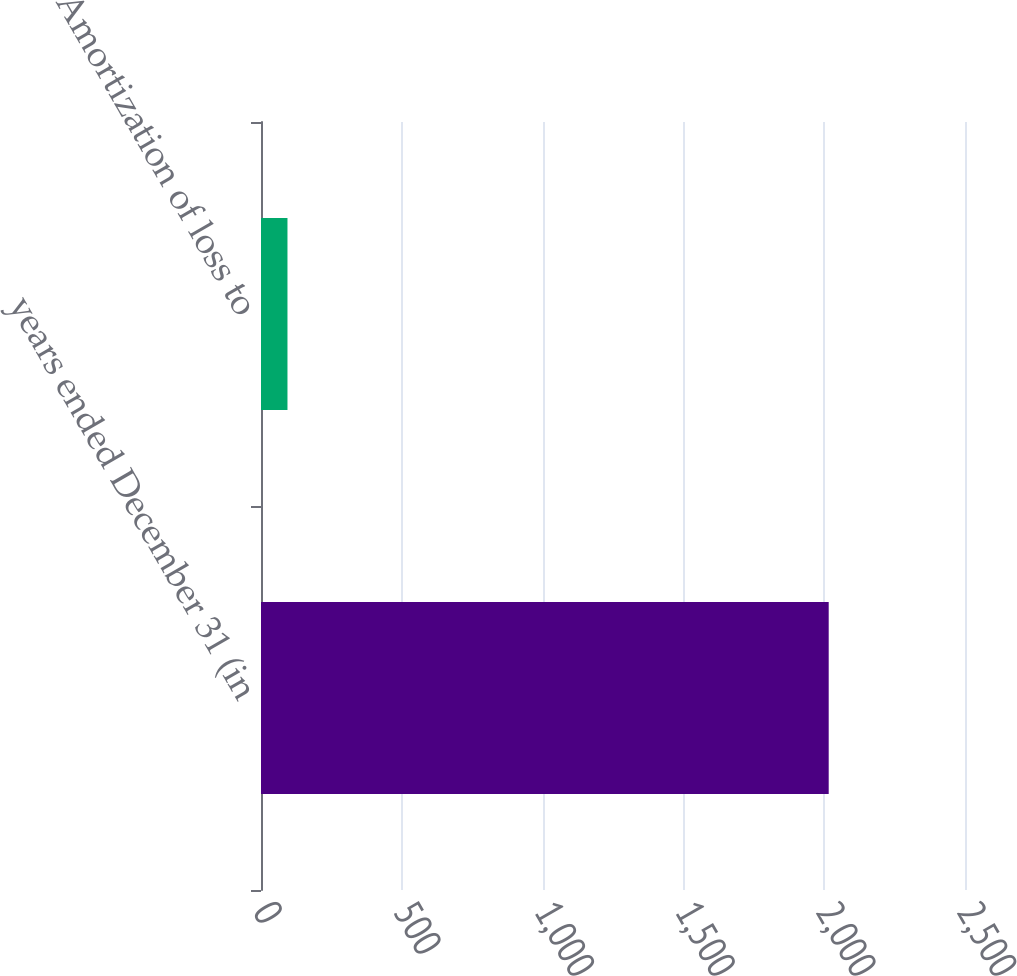Convert chart to OTSL. <chart><loc_0><loc_0><loc_500><loc_500><bar_chart><fcel>years ended December 31 (in<fcel>Amortization of loss to<nl><fcel>2016<fcel>94<nl></chart> 